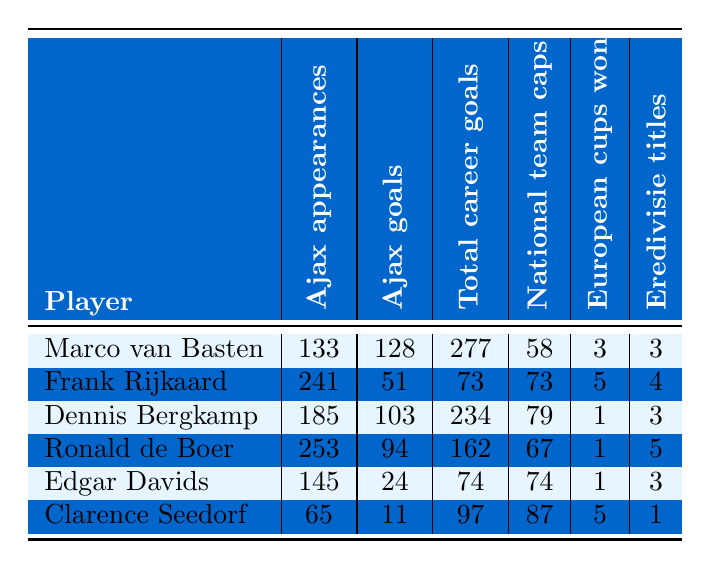What is the total number of Ajax appearances by Marco van Basten? Referring to the table, Marco van Basten's Ajax appearances are listed as 133.
Answer: 133 How many goals did Dennis Bergkamp score for Ajax? The table shows that Dennis Bergkamp scored 103 goals during his time at Ajax.
Answer: 103 Which player has the highest number of total career goals? Comparing the third column, Marco van Basten has the highest total career goals at 277.
Answer: Marco van Basten Did Ronald de Boer win more European cups than Frank Rijkaard? The table shows Ronald de Boer won 1 European cup, while Frank Rijkaard won 5; therefore, the statement is false.
Answer: No What is the difference in Ajax goals between Edgar Davids and Clarence Seedorf? Edgar Davids has 24 Ajax goals, and Clarence Seedorf has 11; the difference is 24 - 11 = 13.
Answer: 13 Which player has the most Ajax appearances, and how many are there? The table indicates Ronald de Boer has the most Ajax appearances at 253.
Answer: Ronald de Boer, 253 What is the average number of European cups won by the players in the table? The total number of European cups won is 3 + 5 + 1 + 1 + 1 + 5 = 16, dividing by 6 players gives an average of 16 / 6 = 2.67.
Answer: 2.67 Is it true that Dennis Bergkamp had more national team caps than Ronald de Boer? According to the table, Dennis Bergkamp has 79 caps, while Ronald de Boer has 67 caps; thus, this statement is true.
Answer: Yes What percentage of total career goals did Frank Rijkaard score while at Ajax? Frank Rijkaard scored 51 goals for Ajax out of 73 total career goals, leading to a percentage of (51/73) * 100 ≈ 69.86%.
Answer: 69.86% Who scored the least number of goals for Ajax and what was that number? The table shows that Clarence Seedorf scored the least for Ajax with 11 goals.
Answer: Clarence Seedorf, 11 